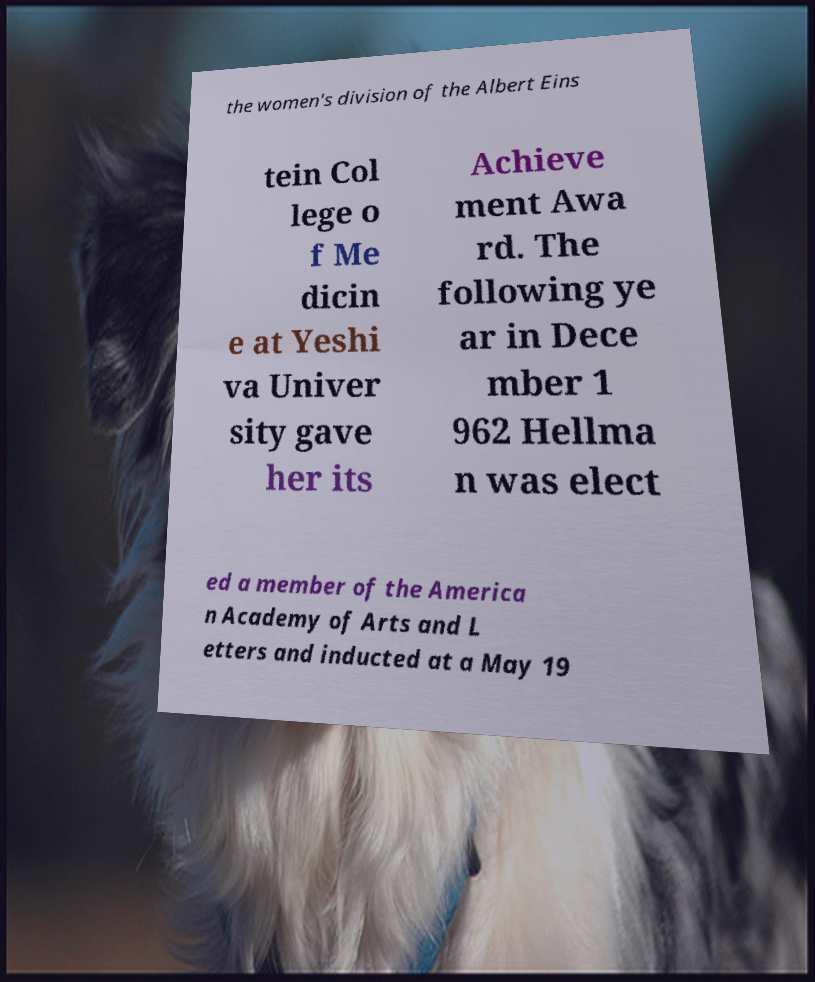There's text embedded in this image that I need extracted. Can you transcribe it verbatim? the women's division of the Albert Eins tein Col lege o f Me dicin e at Yeshi va Univer sity gave her its Achieve ment Awa rd. The following ye ar in Dece mber 1 962 Hellma n was elect ed a member of the America n Academy of Arts and L etters and inducted at a May 19 